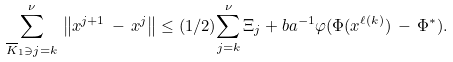<formula> <loc_0><loc_0><loc_500><loc_500>{ \sum _ { \overline { K } _ { 1 } \ni j = k } ^ { \nu } } \, \left \| x ^ { j + 1 } \, - \, x ^ { j } \right \| \leq ( 1 / 2 ) { \sum _ { j = k } ^ { \nu } } \, \Xi _ { j } + b a ^ { - 1 } \varphi ( \Phi ( x ^ { \ell ( k ) } ) \, - \, \Phi ^ { * } ) .</formula> 